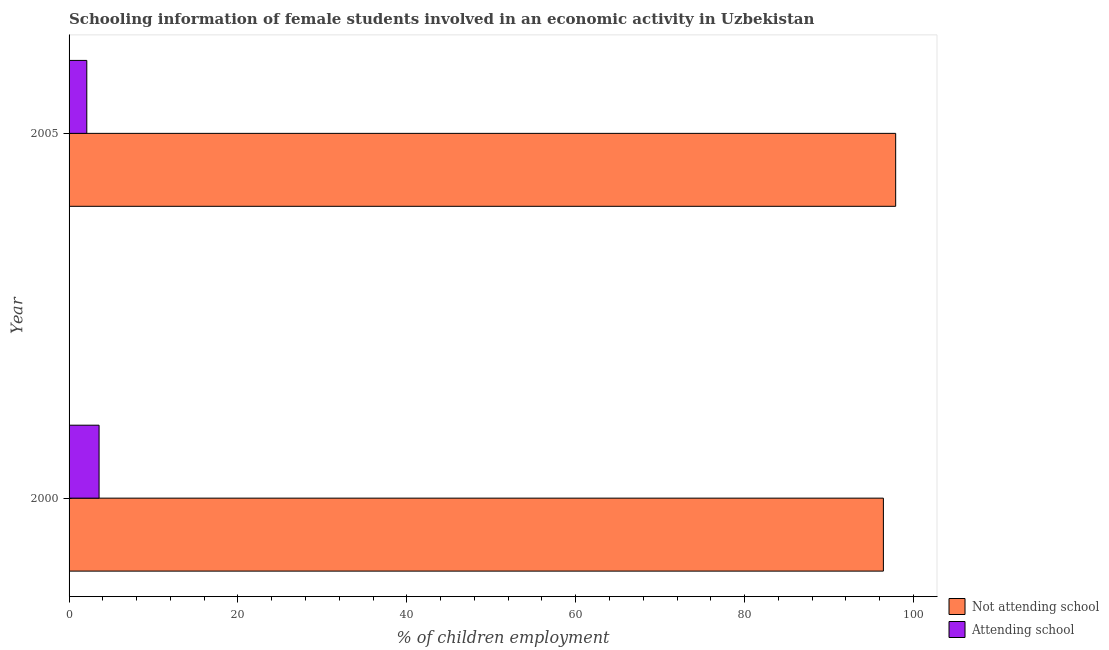Are the number of bars per tick equal to the number of legend labels?
Provide a succinct answer. Yes. Are the number of bars on each tick of the Y-axis equal?
Make the answer very short. Yes. What is the label of the 1st group of bars from the top?
Give a very brief answer. 2005. Across all years, what is the maximum percentage of employed females who are attending school?
Give a very brief answer. 3.55. Across all years, what is the minimum percentage of employed females who are not attending school?
Give a very brief answer. 96.45. In which year was the percentage of employed females who are not attending school maximum?
Provide a succinct answer. 2005. What is the total percentage of employed females who are attending school in the graph?
Your response must be concise. 5.65. What is the difference between the percentage of employed females who are not attending school in 2000 and that in 2005?
Ensure brevity in your answer.  -1.46. What is the difference between the percentage of employed females who are attending school in 2000 and the percentage of employed females who are not attending school in 2005?
Provide a succinct answer. -94.35. What is the average percentage of employed females who are not attending school per year?
Ensure brevity in your answer.  97.17. In the year 2000, what is the difference between the percentage of employed females who are not attending school and percentage of employed females who are attending school?
Offer a terse response. 92.89. In how many years, is the percentage of employed females who are not attending school greater than 12 %?
Your answer should be very brief. 2. Is the difference between the percentage of employed females who are not attending school in 2000 and 2005 greater than the difference between the percentage of employed females who are attending school in 2000 and 2005?
Keep it short and to the point. No. What does the 2nd bar from the top in 2000 represents?
Give a very brief answer. Not attending school. What does the 2nd bar from the bottom in 2000 represents?
Offer a very short reply. Attending school. How many bars are there?
Keep it short and to the point. 4. Are all the bars in the graph horizontal?
Provide a succinct answer. Yes. How many years are there in the graph?
Keep it short and to the point. 2. What is the difference between two consecutive major ticks on the X-axis?
Offer a terse response. 20. Does the graph contain any zero values?
Keep it short and to the point. No. Does the graph contain grids?
Your answer should be compact. No. How are the legend labels stacked?
Your response must be concise. Vertical. What is the title of the graph?
Give a very brief answer. Schooling information of female students involved in an economic activity in Uzbekistan. What is the label or title of the X-axis?
Give a very brief answer. % of children employment. What is the % of children employment of Not attending school in 2000?
Your response must be concise. 96.45. What is the % of children employment of Attending school in 2000?
Offer a terse response. 3.55. What is the % of children employment of Not attending school in 2005?
Keep it short and to the point. 97.9. Across all years, what is the maximum % of children employment of Not attending school?
Provide a short and direct response. 97.9. Across all years, what is the maximum % of children employment of Attending school?
Your response must be concise. 3.55. Across all years, what is the minimum % of children employment in Not attending school?
Make the answer very short. 96.45. Across all years, what is the minimum % of children employment of Attending school?
Provide a succinct answer. 2.1. What is the total % of children employment of Not attending school in the graph?
Keep it short and to the point. 194.35. What is the total % of children employment in Attending school in the graph?
Your response must be concise. 5.65. What is the difference between the % of children employment of Not attending school in 2000 and that in 2005?
Provide a succinct answer. -1.45. What is the difference between the % of children employment of Attending school in 2000 and that in 2005?
Give a very brief answer. 1.45. What is the difference between the % of children employment in Not attending school in 2000 and the % of children employment in Attending school in 2005?
Provide a short and direct response. 94.35. What is the average % of children employment of Not attending school per year?
Offer a terse response. 97.17. What is the average % of children employment of Attending school per year?
Make the answer very short. 2.83. In the year 2000, what is the difference between the % of children employment in Not attending school and % of children employment in Attending school?
Make the answer very short. 92.89. In the year 2005, what is the difference between the % of children employment of Not attending school and % of children employment of Attending school?
Keep it short and to the point. 95.8. What is the ratio of the % of children employment in Not attending school in 2000 to that in 2005?
Your answer should be compact. 0.99. What is the ratio of the % of children employment of Attending school in 2000 to that in 2005?
Provide a short and direct response. 1.69. What is the difference between the highest and the second highest % of children employment of Not attending school?
Give a very brief answer. 1.45. What is the difference between the highest and the second highest % of children employment of Attending school?
Your response must be concise. 1.45. What is the difference between the highest and the lowest % of children employment in Not attending school?
Provide a short and direct response. 1.45. What is the difference between the highest and the lowest % of children employment in Attending school?
Offer a very short reply. 1.45. 